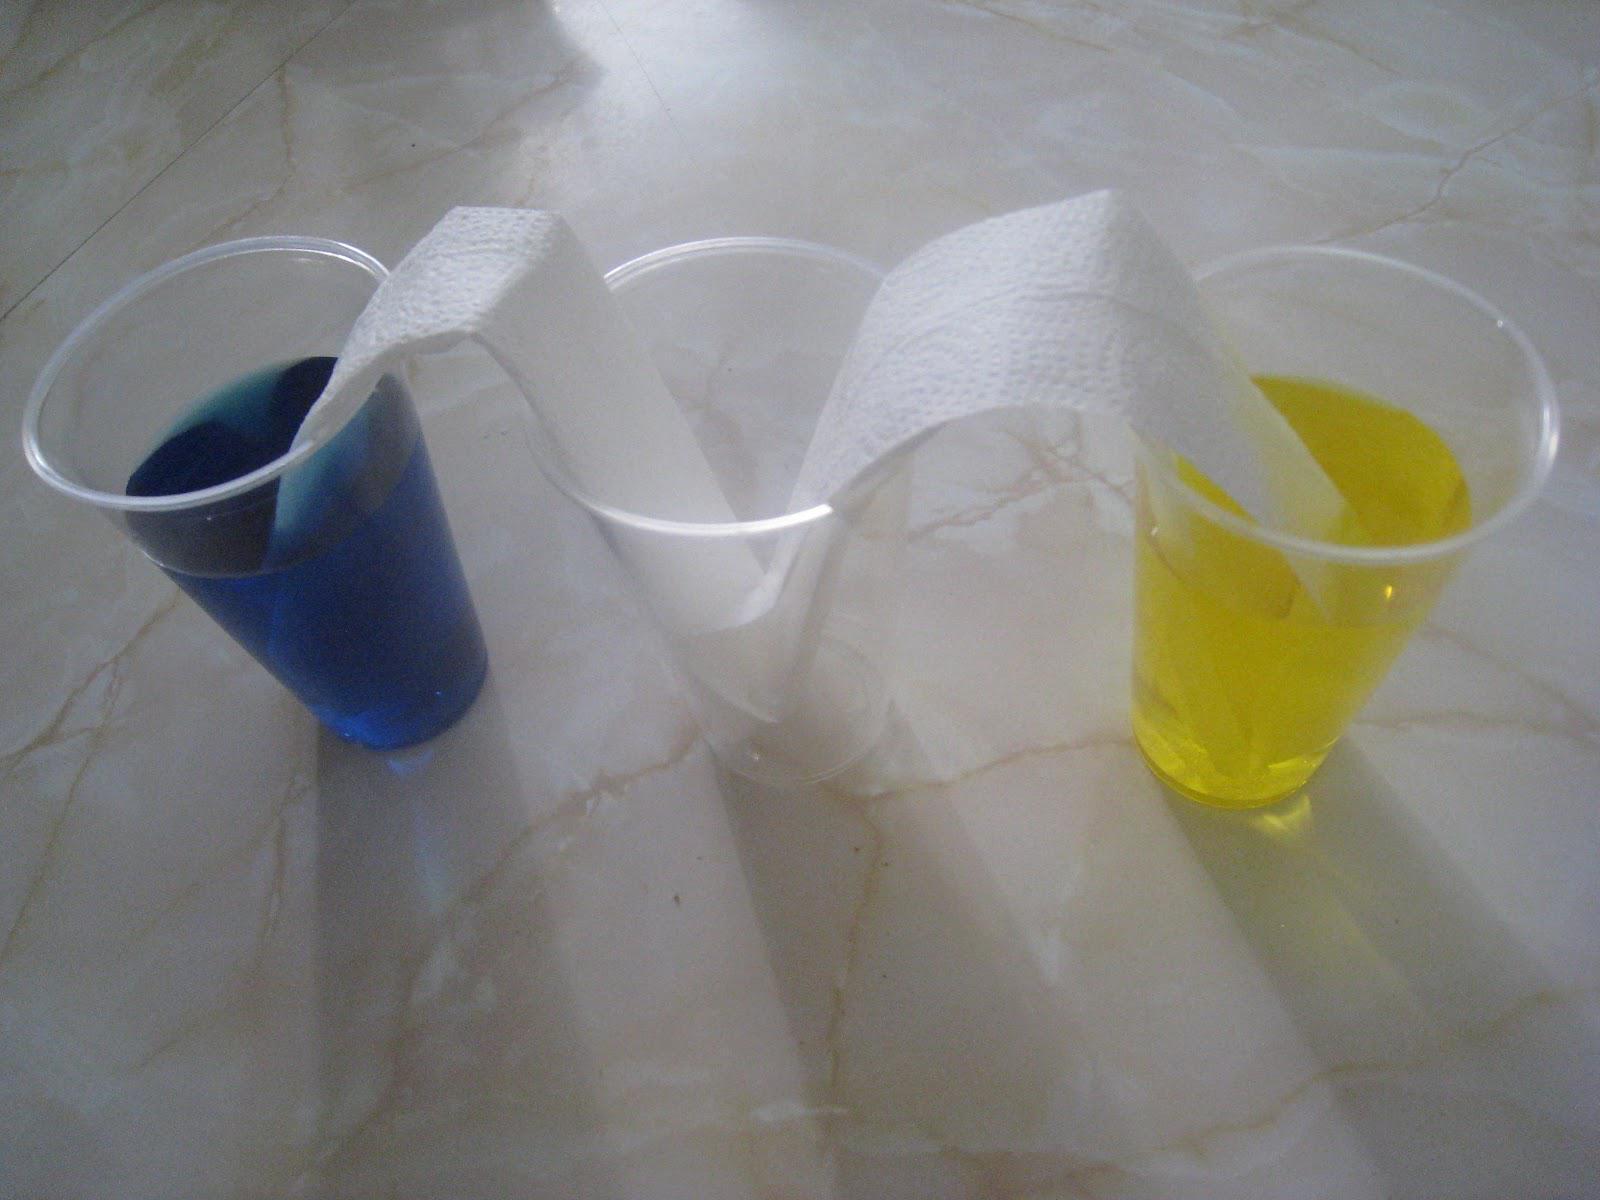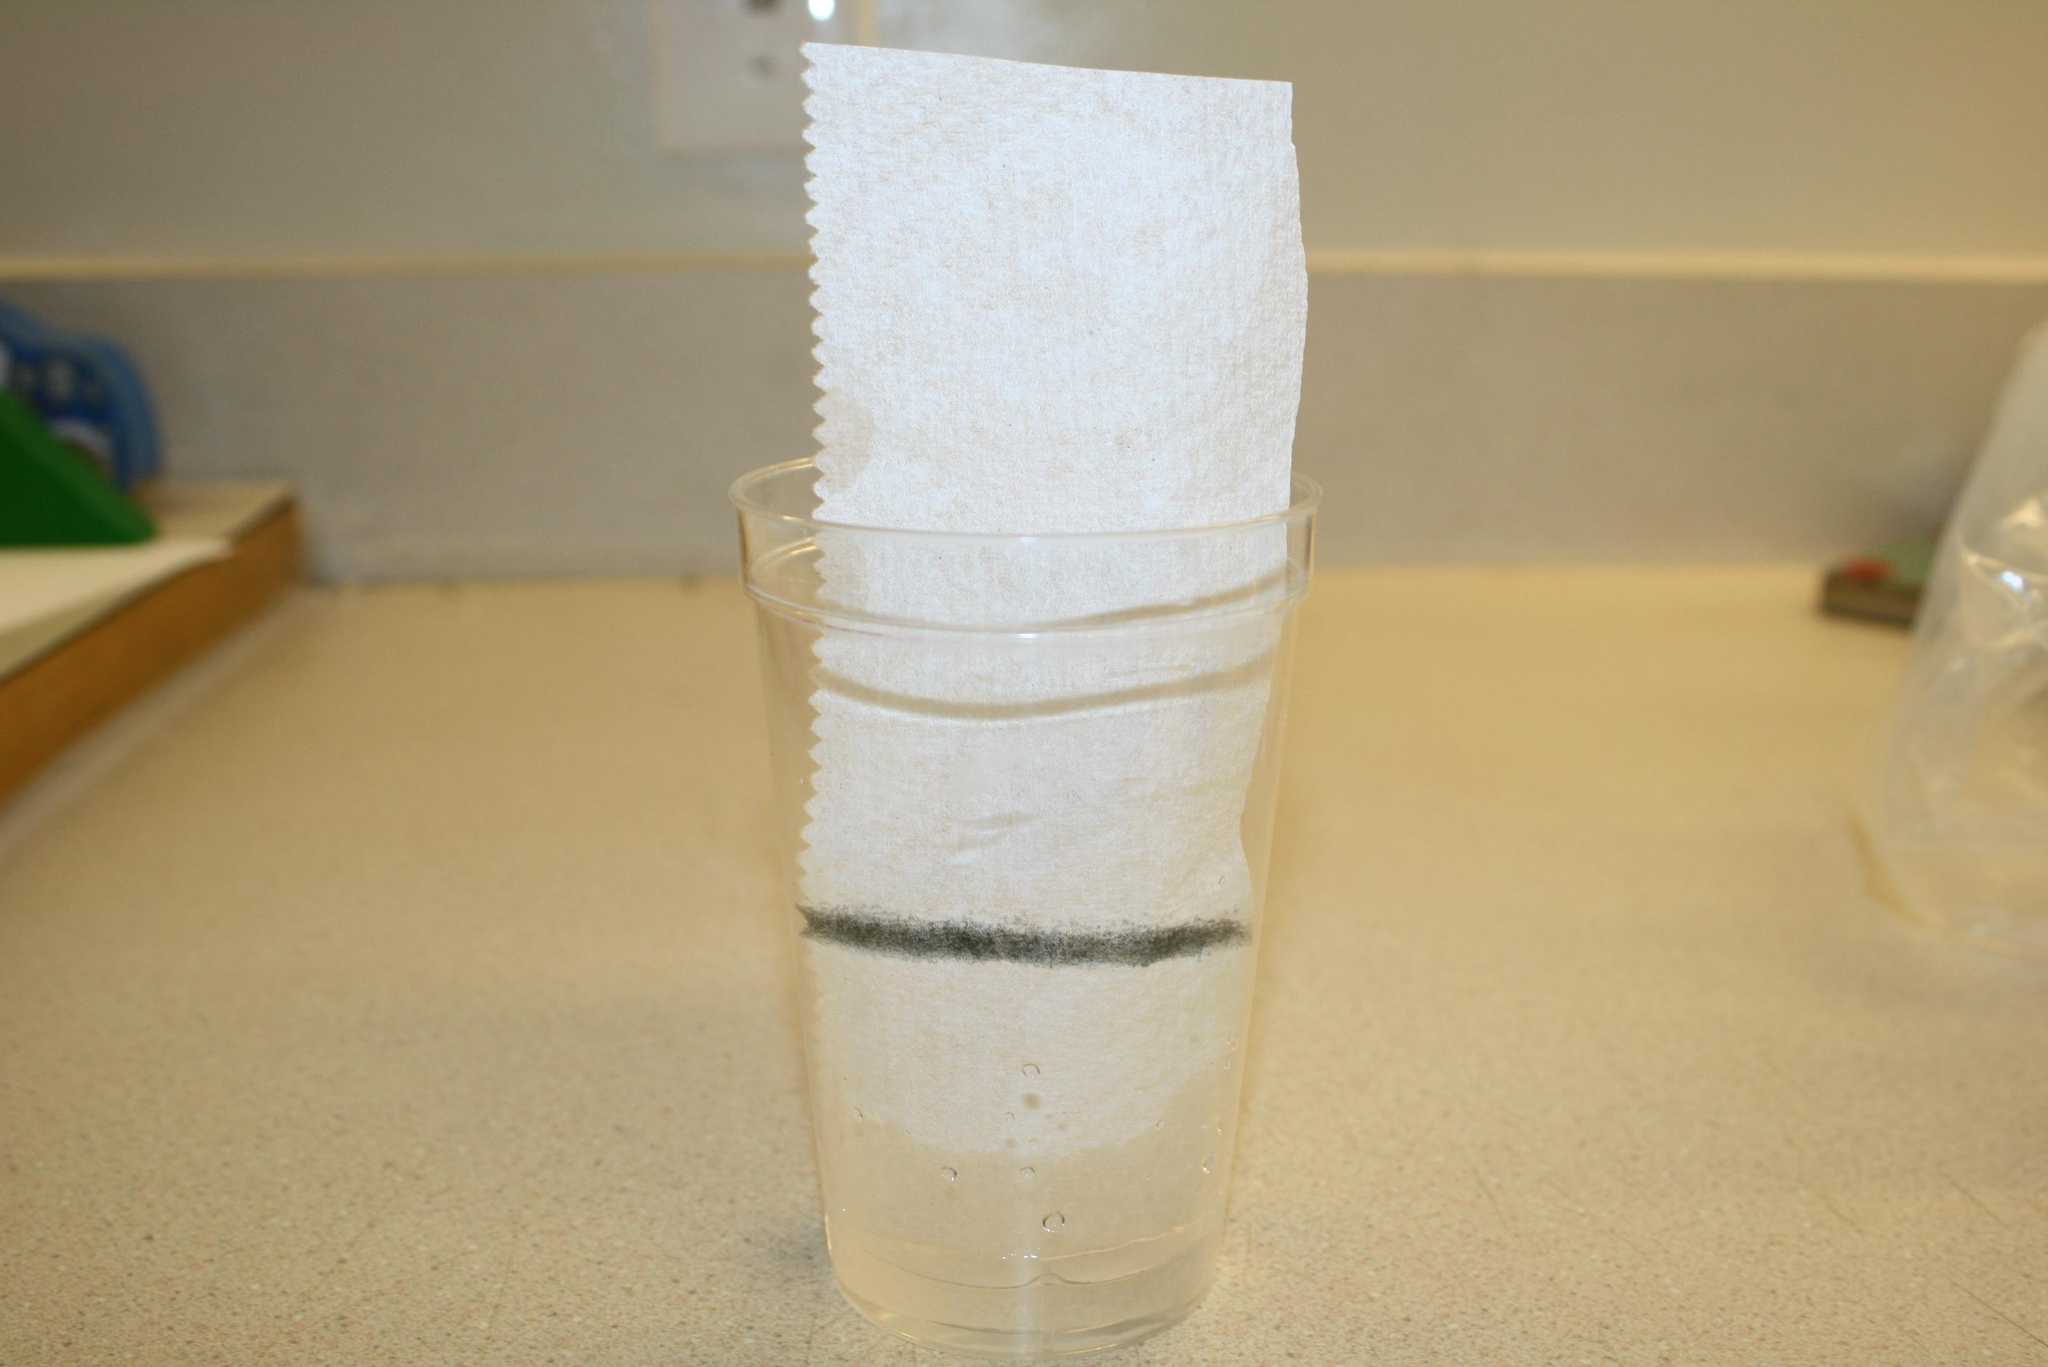The first image is the image on the left, the second image is the image on the right. For the images displayed, is the sentence "A paper towel is soaking in liquid in at least to glasses." factually correct? Answer yes or no. Yes. The first image is the image on the left, the second image is the image on the right. Assess this claim about the two images: "One image shows a paper towel dipped in at least one colored liquid, and the other image includes a glass of clear liquid and a paper towel.". Correct or not? Answer yes or no. Yes. 